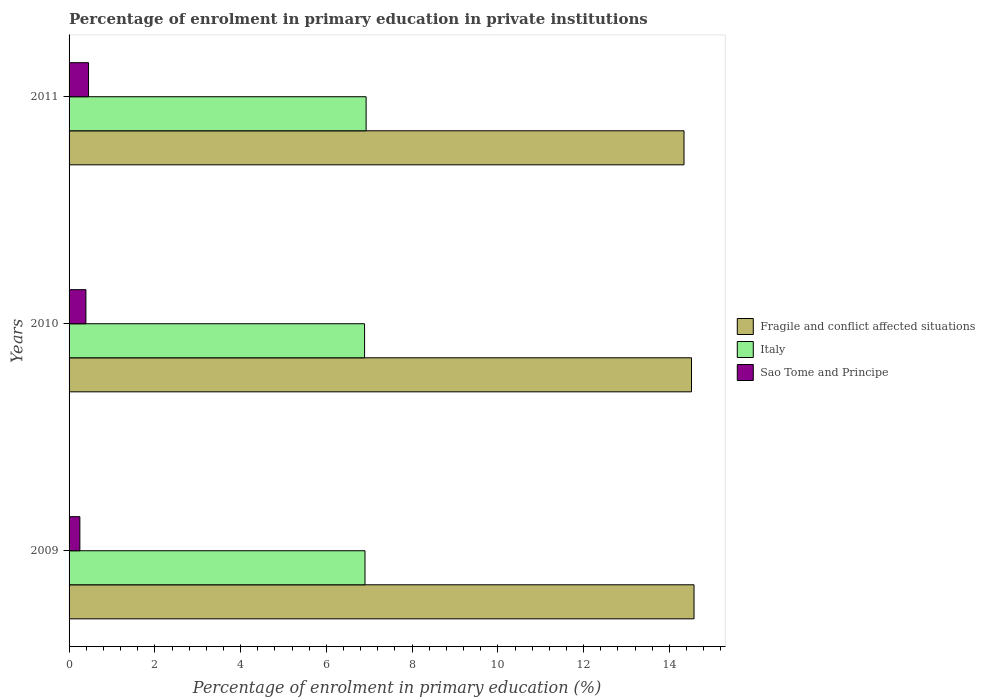How many different coloured bars are there?
Your answer should be very brief. 3. How many bars are there on the 2nd tick from the top?
Offer a terse response. 3. How many bars are there on the 1st tick from the bottom?
Make the answer very short. 3. What is the percentage of enrolment in primary education in Italy in 2010?
Provide a short and direct response. 6.89. Across all years, what is the maximum percentage of enrolment in primary education in Sao Tome and Principe?
Your answer should be compact. 0.45. Across all years, what is the minimum percentage of enrolment in primary education in Fragile and conflict affected situations?
Provide a succinct answer. 14.34. In which year was the percentage of enrolment in primary education in Italy maximum?
Provide a short and direct response. 2011. What is the total percentage of enrolment in primary education in Fragile and conflict affected situations in the graph?
Your answer should be compact. 43.43. What is the difference between the percentage of enrolment in primary education in Italy in 2009 and that in 2011?
Your answer should be compact. -0.03. What is the difference between the percentage of enrolment in primary education in Sao Tome and Principe in 2010 and the percentage of enrolment in primary education in Italy in 2009?
Give a very brief answer. -6.51. What is the average percentage of enrolment in primary education in Italy per year?
Your answer should be very brief. 6.91. In the year 2011, what is the difference between the percentage of enrolment in primary education in Fragile and conflict affected situations and percentage of enrolment in primary education in Italy?
Give a very brief answer. 7.41. In how many years, is the percentage of enrolment in primary education in Fragile and conflict affected situations greater than 5.2 %?
Keep it short and to the point. 3. What is the ratio of the percentage of enrolment in primary education in Italy in 2009 to that in 2011?
Make the answer very short. 1. Is the percentage of enrolment in primary education in Fragile and conflict affected situations in 2010 less than that in 2011?
Ensure brevity in your answer.  No. What is the difference between the highest and the second highest percentage of enrolment in primary education in Sao Tome and Principe?
Make the answer very short. 0.06. What is the difference between the highest and the lowest percentage of enrolment in primary education in Sao Tome and Principe?
Keep it short and to the point. 0.2. What does the 1st bar from the bottom in 2010 represents?
Offer a very short reply. Fragile and conflict affected situations. Is it the case that in every year, the sum of the percentage of enrolment in primary education in Sao Tome and Principe and percentage of enrolment in primary education in Italy is greater than the percentage of enrolment in primary education in Fragile and conflict affected situations?
Your response must be concise. No. How many bars are there?
Your answer should be compact. 9. Are all the bars in the graph horizontal?
Ensure brevity in your answer.  Yes. What is the difference between two consecutive major ticks on the X-axis?
Your response must be concise. 2. Are the values on the major ticks of X-axis written in scientific E-notation?
Your answer should be very brief. No. Does the graph contain grids?
Your answer should be compact. No. Where does the legend appear in the graph?
Offer a very short reply. Center right. How many legend labels are there?
Your answer should be compact. 3. How are the legend labels stacked?
Give a very brief answer. Vertical. What is the title of the graph?
Offer a terse response. Percentage of enrolment in primary education in private institutions. Does "Trinidad and Tobago" appear as one of the legend labels in the graph?
Offer a very short reply. No. What is the label or title of the X-axis?
Provide a short and direct response. Percentage of enrolment in primary education (%). What is the label or title of the Y-axis?
Ensure brevity in your answer.  Years. What is the Percentage of enrolment in primary education (%) in Fragile and conflict affected situations in 2009?
Make the answer very short. 14.57. What is the Percentage of enrolment in primary education (%) in Italy in 2009?
Make the answer very short. 6.9. What is the Percentage of enrolment in primary education (%) of Sao Tome and Principe in 2009?
Keep it short and to the point. 0.25. What is the Percentage of enrolment in primary education (%) in Fragile and conflict affected situations in 2010?
Give a very brief answer. 14.51. What is the Percentage of enrolment in primary education (%) in Italy in 2010?
Give a very brief answer. 6.89. What is the Percentage of enrolment in primary education (%) in Sao Tome and Principe in 2010?
Your answer should be compact. 0.39. What is the Percentage of enrolment in primary education (%) in Fragile and conflict affected situations in 2011?
Offer a terse response. 14.34. What is the Percentage of enrolment in primary education (%) of Italy in 2011?
Give a very brief answer. 6.93. What is the Percentage of enrolment in primary education (%) of Sao Tome and Principe in 2011?
Your answer should be very brief. 0.45. Across all years, what is the maximum Percentage of enrolment in primary education (%) in Fragile and conflict affected situations?
Make the answer very short. 14.57. Across all years, what is the maximum Percentage of enrolment in primary education (%) of Italy?
Offer a terse response. 6.93. Across all years, what is the maximum Percentage of enrolment in primary education (%) of Sao Tome and Principe?
Make the answer very short. 0.45. Across all years, what is the minimum Percentage of enrolment in primary education (%) of Fragile and conflict affected situations?
Offer a very short reply. 14.34. Across all years, what is the minimum Percentage of enrolment in primary education (%) of Italy?
Offer a terse response. 6.89. Across all years, what is the minimum Percentage of enrolment in primary education (%) in Sao Tome and Principe?
Provide a succinct answer. 0.25. What is the total Percentage of enrolment in primary education (%) in Fragile and conflict affected situations in the graph?
Offer a terse response. 43.43. What is the total Percentage of enrolment in primary education (%) in Italy in the graph?
Your answer should be compact. 20.72. What is the total Percentage of enrolment in primary education (%) of Sao Tome and Principe in the graph?
Offer a very short reply. 1.1. What is the difference between the Percentage of enrolment in primary education (%) in Fragile and conflict affected situations in 2009 and that in 2010?
Offer a terse response. 0.06. What is the difference between the Percentage of enrolment in primary education (%) in Italy in 2009 and that in 2010?
Give a very brief answer. 0.01. What is the difference between the Percentage of enrolment in primary education (%) in Sao Tome and Principe in 2009 and that in 2010?
Keep it short and to the point. -0.14. What is the difference between the Percentage of enrolment in primary education (%) in Fragile and conflict affected situations in 2009 and that in 2011?
Provide a succinct answer. 0.23. What is the difference between the Percentage of enrolment in primary education (%) in Italy in 2009 and that in 2011?
Keep it short and to the point. -0.03. What is the difference between the Percentage of enrolment in primary education (%) of Sao Tome and Principe in 2009 and that in 2011?
Make the answer very short. -0.2. What is the difference between the Percentage of enrolment in primary education (%) in Fragile and conflict affected situations in 2010 and that in 2011?
Your answer should be compact. 0.17. What is the difference between the Percentage of enrolment in primary education (%) of Italy in 2010 and that in 2011?
Provide a succinct answer. -0.04. What is the difference between the Percentage of enrolment in primary education (%) of Sao Tome and Principe in 2010 and that in 2011?
Offer a very short reply. -0.06. What is the difference between the Percentage of enrolment in primary education (%) in Fragile and conflict affected situations in 2009 and the Percentage of enrolment in primary education (%) in Italy in 2010?
Keep it short and to the point. 7.68. What is the difference between the Percentage of enrolment in primary education (%) of Fragile and conflict affected situations in 2009 and the Percentage of enrolment in primary education (%) of Sao Tome and Principe in 2010?
Ensure brevity in your answer.  14.18. What is the difference between the Percentage of enrolment in primary education (%) of Italy in 2009 and the Percentage of enrolment in primary education (%) of Sao Tome and Principe in 2010?
Keep it short and to the point. 6.51. What is the difference between the Percentage of enrolment in primary education (%) of Fragile and conflict affected situations in 2009 and the Percentage of enrolment in primary education (%) of Italy in 2011?
Ensure brevity in your answer.  7.65. What is the difference between the Percentage of enrolment in primary education (%) in Fragile and conflict affected situations in 2009 and the Percentage of enrolment in primary education (%) in Sao Tome and Principe in 2011?
Give a very brief answer. 14.12. What is the difference between the Percentage of enrolment in primary education (%) in Italy in 2009 and the Percentage of enrolment in primary education (%) in Sao Tome and Principe in 2011?
Your answer should be compact. 6.45. What is the difference between the Percentage of enrolment in primary education (%) in Fragile and conflict affected situations in 2010 and the Percentage of enrolment in primary education (%) in Italy in 2011?
Your response must be concise. 7.59. What is the difference between the Percentage of enrolment in primary education (%) in Fragile and conflict affected situations in 2010 and the Percentage of enrolment in primary education (%) in Sao Tome and Principe in 2011?
Make the answer very short. 14.06. What is the difference between the Percentage of enrolment in primary education (%) of Italy in 2010 and the Percentage of enrolment in primary education (%) of Sao Tome and Principe in 2011?
Offer a very short reply. 6.44. What is the average Percentage of enrolment in primary education (%) of Fragile and conflict affected situations per year?
Provide a succinct answer. 14.48. What is the average Percentage of enrolment in primary education (%) of Italy per year?
Your answer should be compact. 6.91. What is the average Percentage of enrolment in primary education (%) of Sao Tome and Principe per year?
Ensure brevity in your answer.  0.37. In the year 2009, what is the difference between the Percentage of enrolment in primary education (%) of Fragile and conflict affected situations and Percentage of enrolment in primary education (%) of Italy?
Offer a terse response. 7.67. In the year 2009, what is the difference between the Percentage of enrolment in primary education (%) in Fragile and conflict affected situations and Percentage of enrolment in primary education (%) in Sao Tome and Principe?
Keep it short and to the point. 14.32. In the year 2009, what is the difference between the Percentage of enrolment in primary education (%) in Italy and Percentage of enrolment in primary education (%) in Sao Tome and Principe?
Make the answer very short. 6.65. In the year 2010, what is the difference between the Percentage of enrolment in primary education (%) of Fragile and conflict affected situations and Percentage of enrolment in primary education (%) of Italy?
Give a very brief answer. 7.62. In the year 2010, what is the difference between the Percentage of enrolment in primary education (%) of Fragile and conflict affected situations and Percentage of enrolment in primary education (%) of Sao Tome and Principe?
Ensure brevity in your answer.  14.12. In the year 2010, what is the difference between the Percentage of enrolment in primary education (%) of Italy and Percentage of enrolment in primary education (%) of Sao Tome and Principe?
Offer a terse response. 6.5. In the year 2011, what is the difference between the Percentage of enrolment in primary education (%) in Fragile and conflict affected situations and Percentage of enrolment in primary education (%) in Italy?
Keep it short and to the point. 7.41. In the year 2011, what is the difference between the Percentage of enrolment in primary education (%) in Fragile and conflict affected situations and Percentage of enrolment in primary education (%) in Sao Tome and Principe?
Your answer should be very brief. 13.89. In the year 2011, what is the difference between the Percentage of enrolment in primary education (%) in Italy and Percentage of enrolment in primary education (%) in Sao Tome and Principe?
Your answer should be compact. 6.47. What is the ratio of the Percentage of enrolment in primary education (%) in Italy in 2009 to that in 2010?
Provide a succinct answer. 1. What is the ratio of the Percentage of enrolment in primary education (%) of Sao Tome and Principe in 2009 to that in 2010?
Give a very brief answer. 0.64. What is the ratio of the Percentage of enrolment in primary education (%) of Fragile and conflict affected situations in 2009 to that in 2011?
Provide a short and direct response. 1.02. What is the ratio of the Percentage of enrolment in primary education (%) in Sao Tome and Principe in 2009 to that in 2011?
Ensure brevity in your answer.  0.55. What is the ratio of the Percentage of enrolment in primary education (%) of Fragile and conflict affected situations in 2010 to that in 2011?
Ensure brevity in your answer.  1.01. What is the ratio of the Percentage of enrolment in primary education (%) of Sao Tome and Principe in 2010 to that in 2011?
Provide a short and direct response. 0.87. What is the difference between the highest and the second highest Percentage of enrolment in primary education (%) of Fragile and conflict affected situations?
Provide a short and direct response. 0.06. What is the difference between the highest and the second highest Percentage of enrolment in primary education (%) of Italy?
Give a very brief answer. 0.03. What is the difference between the highest and the second highest Percentage of enrolment in primary education (%) in Sao Tome and Principe?
Give a very brief answer. 0.06. What is the difference between the highest and the lowest Percentage of enrolment in primary education (%) of Fragile and conflict affected situations?
Provide a succinct answer. 0.23. What is the difference between the highest and the lowest Percentage of enrolment in primary education (%) of Italy?
Your answer should be compact. 0.04. What is the difference between the highest and the lowest Percentage of enrolment in primary education (%) of Sao Tome and Principe?
Ensure brevity in your answer.  0.2. 